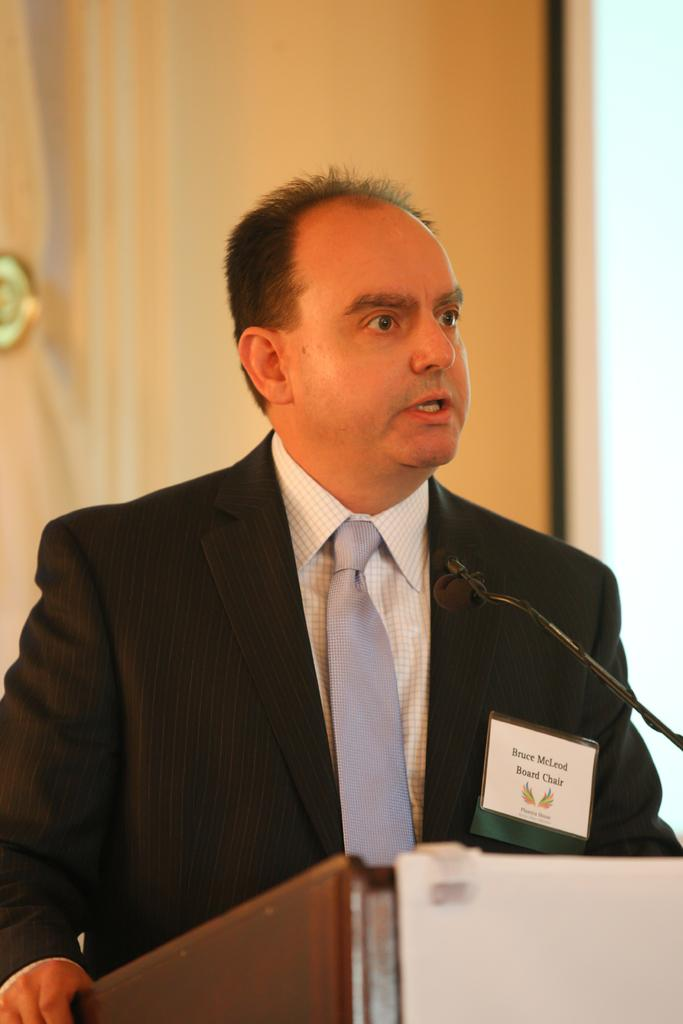What is the main subject of the image? The main subject of the image is a man. What is the man doing in the image? The man is standing and speaking in the image. What object is present in the image that might be related to the man's activity? There is a microphone in the image. Can you see any hills in the background of the image? There is no mention of a hill or any background in the provided facts, so it cannot be determined if there are any hills visible in the image. What type of vest is the man wearing in the image? There is no mention of a vest or any clothing details in the provided facts, so it cannot be determined what type of vest the man might be wearing. 